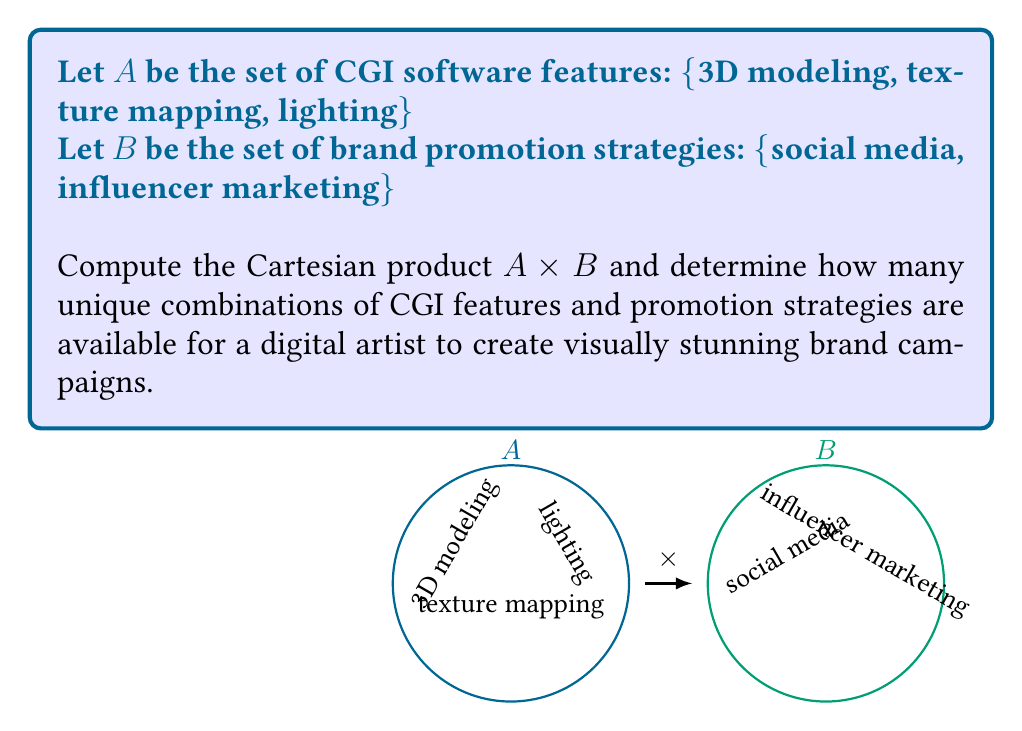Can you solve this math problem? To compute the Cartesian product $A \times B$, we need to pair each element from set A with every element from set B. Let's follow these steps:

1) First, let's list out our sets:
   $A = \{3D modeling, texture mapping, lighting\}$
   $B = \{social media, influencer marketing\}$

2) The Cartesian product $A \times B$ is defined as:
   $A \times B = \{(a,b) | a \in A \text{ and } b \in B\}$

3) Now, let's pair each element from A with each element from B:
   
   (3D modeling, social media)
   (3D modeling, influencer marketing)
   (texture mapping, social media)
   (texture mapping, influencer marketing)
   (lighting, social media)
   (lighting, influencer marketing)

4) To count the number of unique combinations, we can use the multiplication principle:
   $|A \times B| = |A| \cdot |B|$
   
   Where $|A|$ is the number of elements in set A, and $|B|$ is the number of elements in set B.

5) In this case:
   $|A| = 3$ (3D modeling, texture mapping, lighting)
   $|B| = 2$ (social media, influencer marketing)

6) Therefore, the number of unique combinations is:
   $|A \times B| = 3 \cdot 2 = 6$

This means there are 6 unique combinations of CGI features and promotion strategies available for a digital artist to create visually stunning brand campaigns.
Answer: $|A \times B| = 6$ 